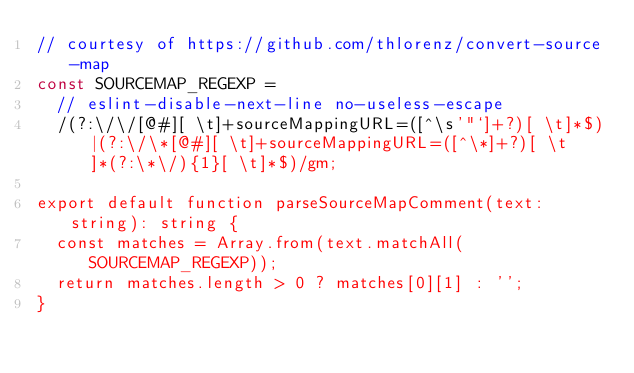Convert code to text. <code><loc_0><loc_0><loc_500><loc_500><_TypeScript_>// courtesy of https://github.com/thlorenz/convert-source-map
const SOURCEMAP_REGEXP =
  // eslint-disable-next-line no-useless-escape
  /(?:\/\/[@#][ \t]+sourceMappingURL=([^\s'"`]+?)[ \t]*$)|(?:\/\*[@#][ \t]+sourceMappingURL=([^\*]+?)[ \t]*(?:\*\/){1}[ \t]*$)/gm;

export default function parseSourceMapComment(text: string): string {
  const matches = Array.from(text.matchAll(SOURCEMAP_REGEXP));
  return matches.length > 0 ? matches[0][1] : '';
}
</code> 